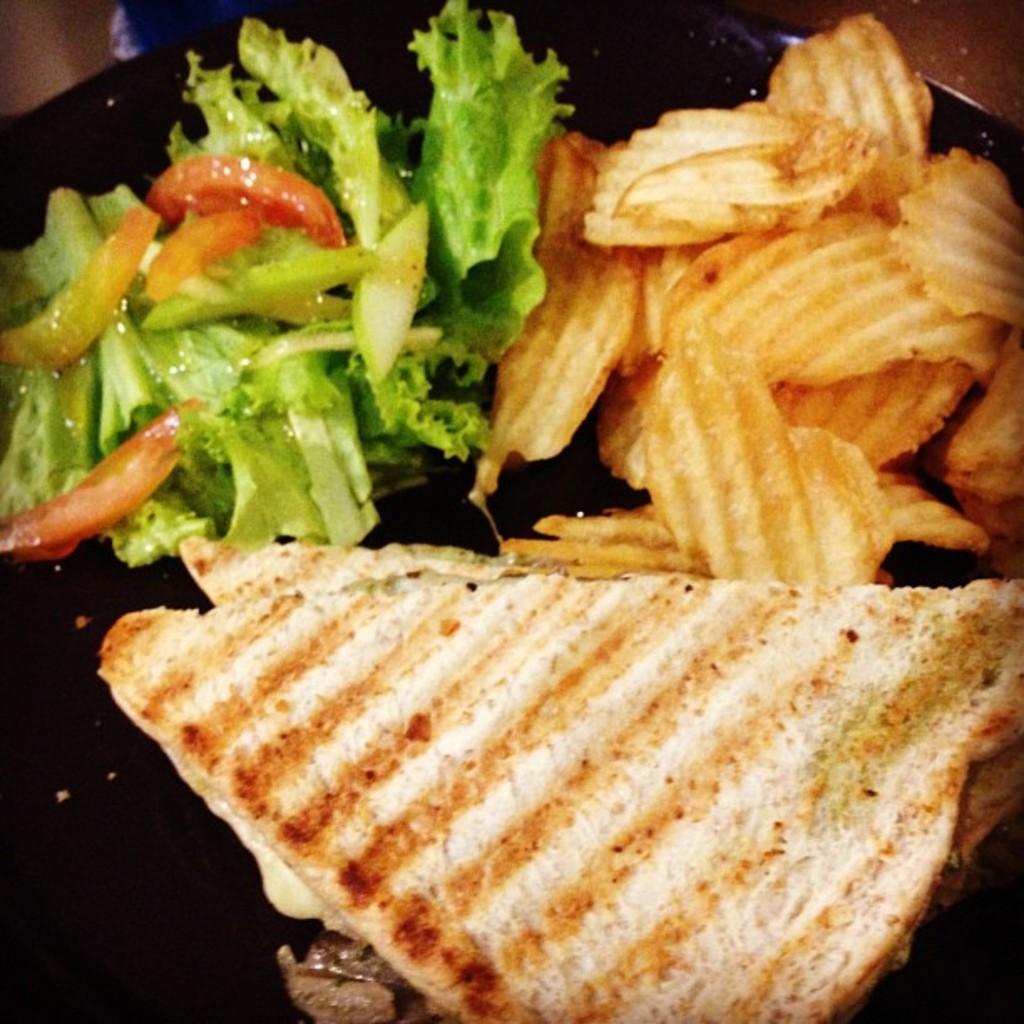Can you describe this image briefly? In this image we can see some food in a plate which is placed on the surface. 